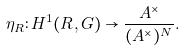<formula> <loc_0><loc_0><loc_500><loc_500>\eta _ { R } \colon H ^ { 1 } ( R , G ) \to \frac { A ^ { \times } } { ( A ^ { \times } ) ^ { N } } .</formula> 